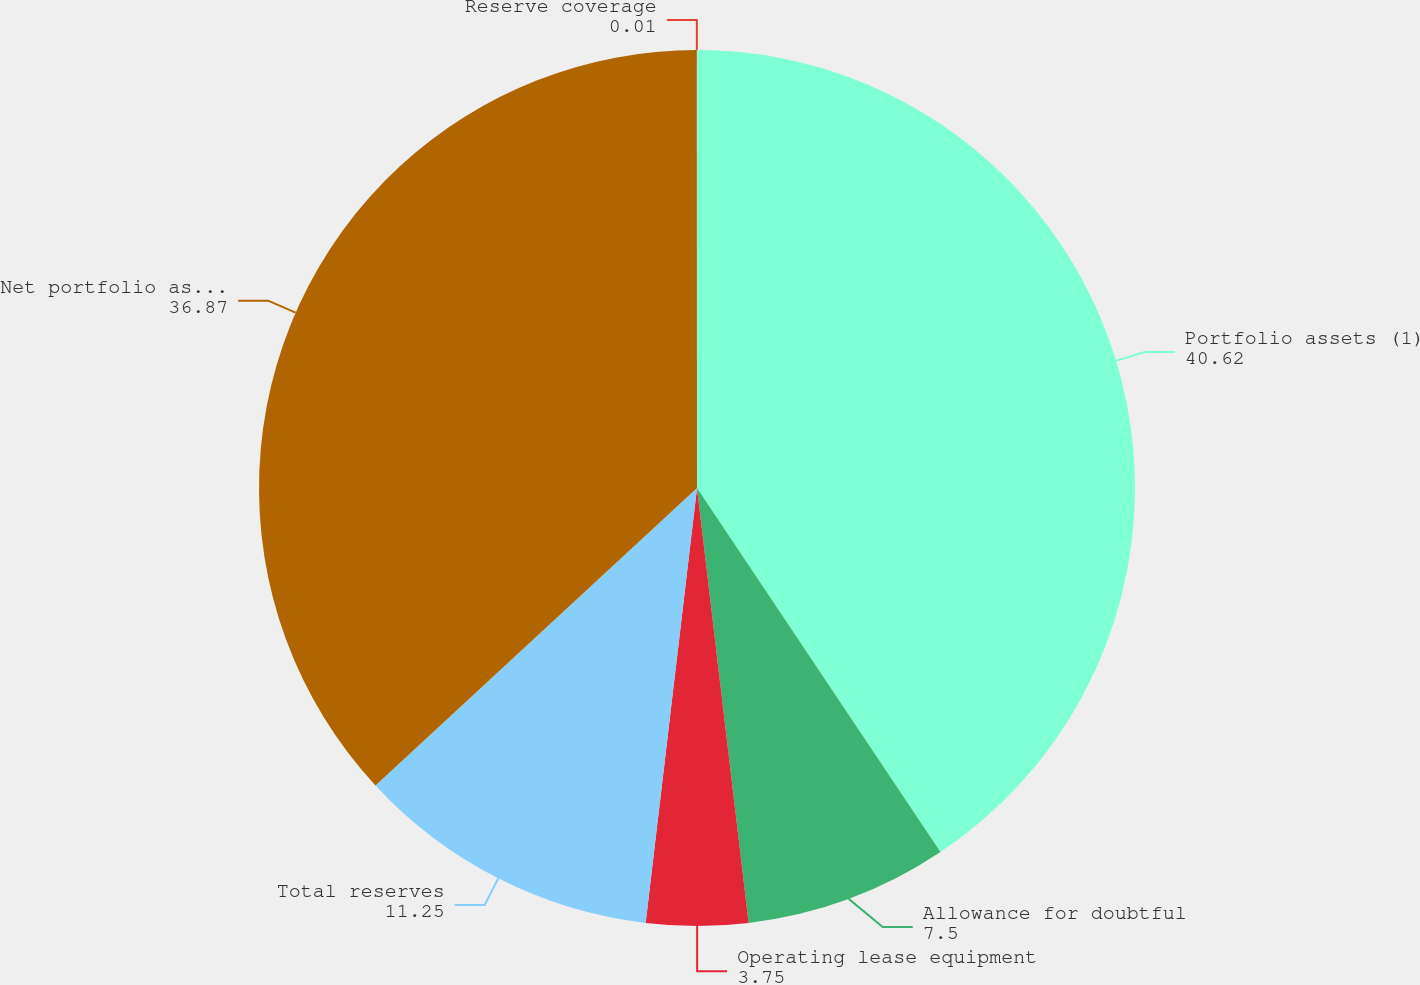Convert chart to OTSL. <chart><loc_0><loc_0><loc_500><loc_500><pie_chart><fcel>Portfolio assets (1)<fcel>Allowance for doubtful<fcel>Operating lease equipment<fcel>Total reserves<fcel>Net portfolio assets<fcel>Reserve coverage<nl><fcel>40.62%<fcel>7.5%<fcel>3.75%<fcel>11.25%<fcel>36.87%<fcel>0.01%<nl></chart> 